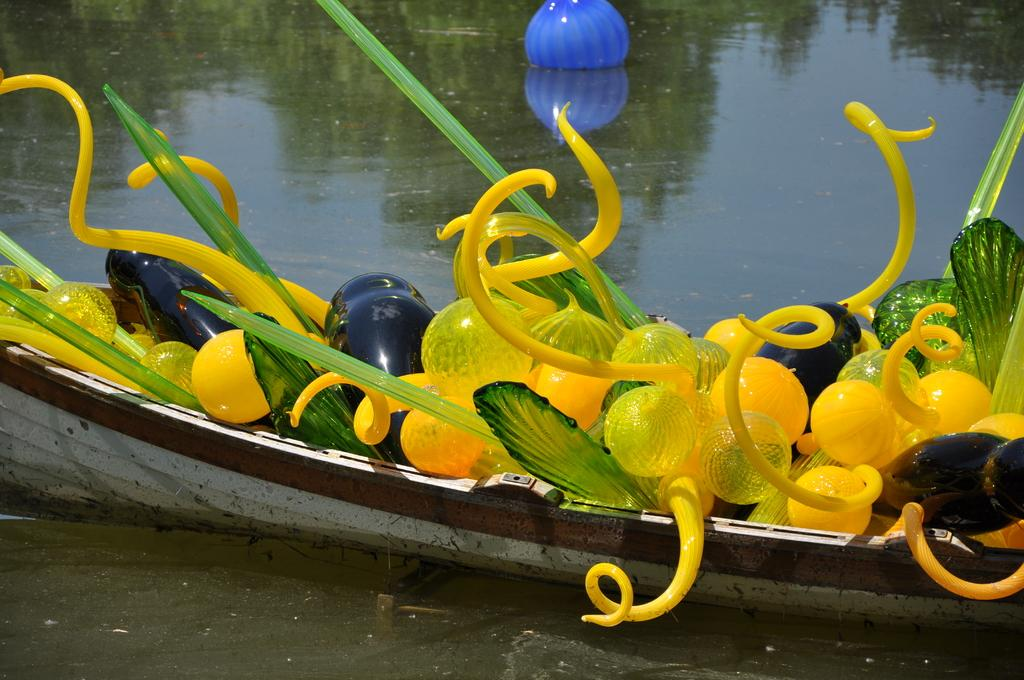What is the main subject of the picture? The main subject of the picture is a boat. Where is the boat located? The boat is on the water. What can be found inside the boat? There are objects in the boat. What can be said about the appearance of the objects? The objects have different colors. Are there any cubs playing with the objects in the boat? There is no mention of cubs or any animals in the image; it only features a boat with objects inside. 